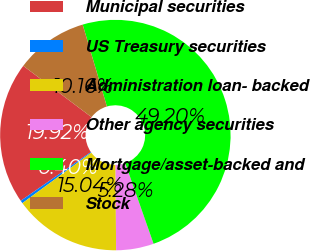Convert chart to OTSL. <chart><loc_0><loc_0><loc_500><loc_500><pie_chart><fcel>Municipal securities<fcel>US Treasury securities<fcel>Administration loan- backed<fcel>Other agency securities<fcel>Mortgage/asset-backed and<fcel>Stock<nl><fcel>19.92%<fcel>0.4%<fcel>15.04%<fcel>5.28%<fcel>49.2%<fcel>10.16%<nl></chart> 